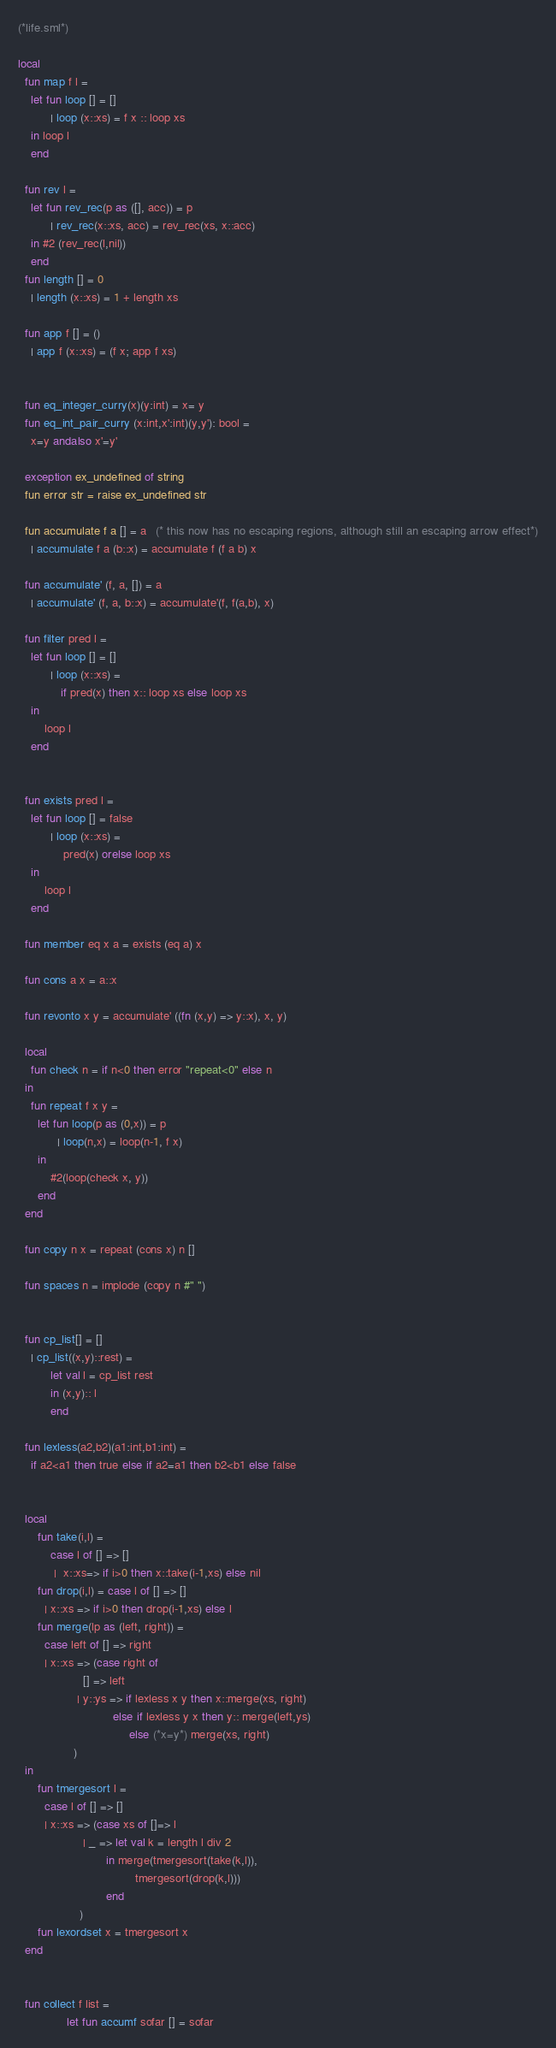Convert code to text. <code><loc_0><loc_0><loc_500><loc_500><_SML_>(*life.sml*)

local
  fun map f l =
    let fun loop [] = []
          | loop (x::xs) = f x :: loop xs
    in loop l
    end

  fun rev l =
    let fun rev_rec(p as ([], acc)) = p
          | rev_rec(x::xs, acc) = rev_rec(xs, x::acc)
    in #2 (rev_rec(l,nil))
    end
  fun length [] = 0
    | length (x::xs) = 1 + length xs

  fun app f [] = ()
    | app f (x::xs) = (f x; app f xs)


  fun eq_integer_curry(x)(y:int) = x= y
  fun eq_int_pair_curry (x:int,x':int)(y,y'): bool =
    x=y andalso x'=y'

  exception ex_undefined of string
  fun error str = raise ex_undefined str

  fun accumulate f a [] = a   (* this now has no escaping regions, although still an escaping arrow effect*)
    | accumulate f a (b::x) = accumulate f (f a b) x

  fun accumulate' (f, a, []) = a
    | accumulate' (f, a, b::x) = accumulate'(f, f(a,b), x)

  fun filter pred l =
    let fun loop [] = []
          | loop (x::xs) =
             if pred(x) then x:: loop xs else loop xs
    in
        loop l
    end


  fun exists pred l =
    let fun loop [] = false
          | loop (x::xs) =
              pred(x) orelse loop xs
    in
        loop l
    end

  fun member eq x a = exists (eq a) x

  fun cons a x = a::x

  fun revonto x y = accumulate' ((fn (x,y) => y::x), x, y)

  local
    fun check n = if n<0 then error "repeat<0" else n
  in
    fun repeat f x y =
      let fun loop(p as (0,x)) = p
            | loop(n,x) = loop(n-1, f x)
      in
          #2(loop(check x, y))
      end
  end

  fun copy n x = repeat (cons x) n []

  fun spaces n = implode (copy n #" ")


  fun cp_list[] = []
    | cp_list((x,y)::rest) =
          let val l = cp_list rest
          in (x,y):: l
          end

  fun lexless(a2,b2)(a1:int,b1:int) =
    if a2<a1 then true else if a2=a1 then b2<b1 else false


  local
      fun take(i,l) =
          case l of [] => []
           |  x::xs=> if i>0 then x::take(i-1,xs) else nil
      fun drop(i,l) = case l of [] => []
        | x::xs => if i>0 then drop(i-1,xs) else l
      fun merge(lp as (left, right)) =
        case left of [] => right
        | x::xs => (case right of
                    [] => left
                  | y::ys => if lexless x y then x::merge(xs, right)
                             else if lexless y x then y:: merge(left,ys)
                                  else (*x=y*) merge(xs, right)
                 )
  in
      fun tmergesort l =
        case l of [] => []
        | x::xs => (case xs of []=> l
                    | _ => let val k = length l div 2
                           in merge(tmergesort(take(k,l)),
                                    tmergesort(drop(k,l)))
                           end
                   )
      fun lexordset x = tmergesort x
  end


  fun collect f list =
               let fun accumf sofar [] = sofar</code> 